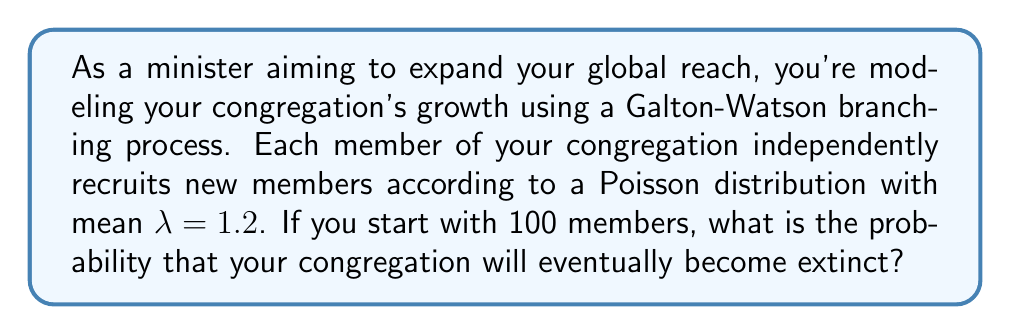Teach me how to tackle this problem. To solve this problem, we'll use the theory of branching processes:

1) In a Galton-Watson branching process, the extinction probability $q$ satisfies the equation:

   $$q = G(q)$$

   where $G(s)$ is the probability generating function of the offspring distribution.

2) For a Poisson distribution with mean $\lambda$, the probability generating function is:

   $$G(s) = e^{\lambda(s-1)}$$

3) Therefore, we need to solve the equation:

   $$q = e^{\lambda(q-1)}$$

4) Given $\lambda = 1.2$, we have:

   $$q = e^{1.2(q-1)}$$

5) This equation can't be solved analytically, but we can solve it numerically. Using numerical methods (e.g., Newton-Raphson), we find:

   $$q \approx 0.7553$$

6) This is the probability that a single member's "family line" will go extinct.

7) For 100 independent starting members, the probability that all their family lines go extinct is:

   $$q^{100} \approx 0.7553^{100} \approx 1.65 \times 10^{-11}$$

8) Therefore, the probability that the congregation will eventually become extinct is approximately $1.65 \times 10^{-11}$.
Answer: $1.65 \times 10^{-11}$ 